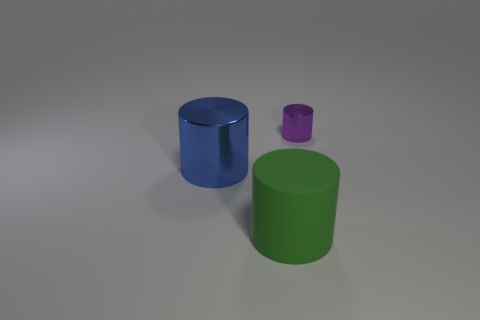Add 3 large gray balls. How many objects exist? 6 Subtract all blue shiny cylinders. Subtract all big metal objects. How many objects are left? 1 Add 1 purple metallic things. How many purple metallic things are left? 2 Add 1 tiny blue matte spheres. How many tiny blue matte spheres exist? 1 Subtract 0 brown balls. How many objects are left? 3 